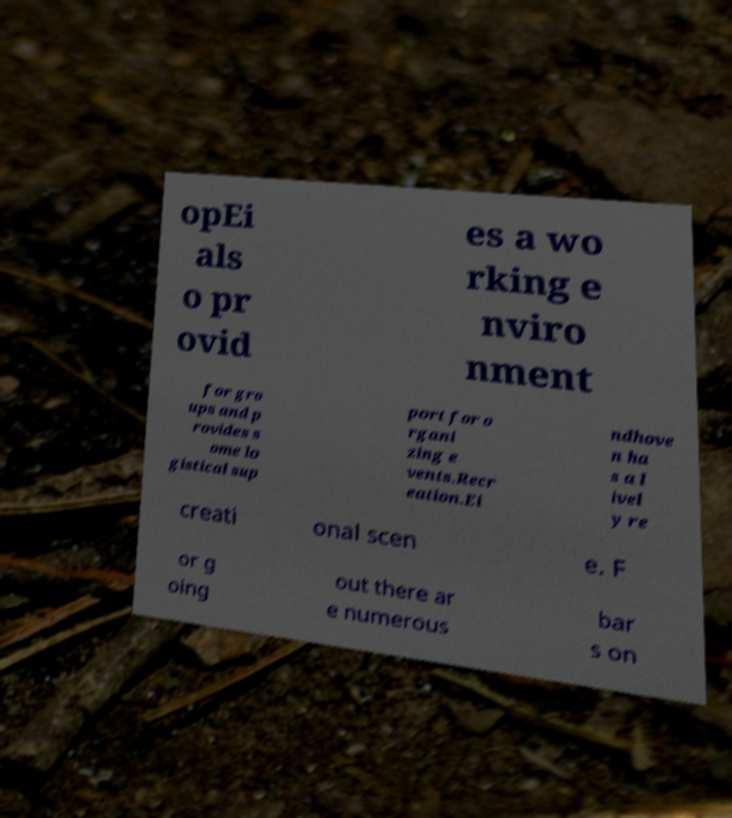There's text embedded in this image that I need extracted. Can you transcribe it verbatim? opEi als o pr ovid es a wo rking e nviro nment for gro ups and p rovides s ome lo gistical sup port for o rgani zing e vents.Recr eation.Ei ndhove n ha s a l ivel y re creati onal scen e. F or g oing out there ar e numerous bar s on 